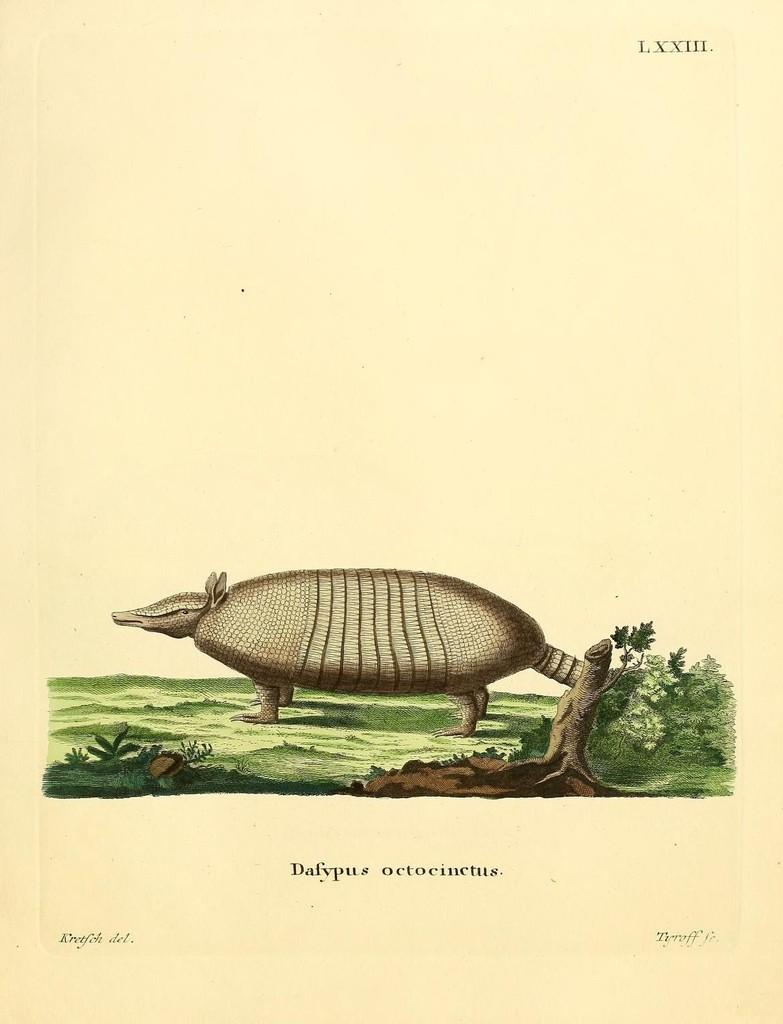What is depicted on the paper in the image? There is an animal drawing on a paper. What else can be seen on the paper besides the drawing? There is writing on the paper. What type of lamp is used to illuminate the drawing in the image? There is no lamp present in the image; it only shows a paper with an animal drawing and writing on it. What observations can be made about the weather based on the image? The image does not provide any information about the weather, as it only shows a paper with an animal drawing and writing on it. 